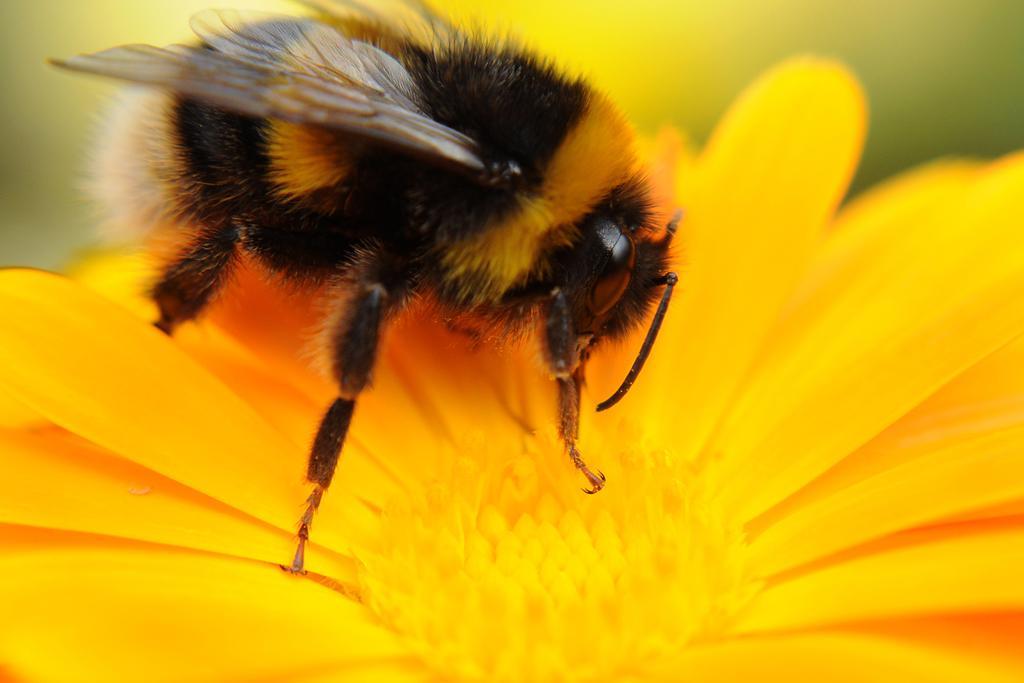Can you describe this image briefly? In this picture we can see a honey bee on the flower. 